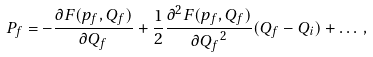<formula> <loc_0><loc_0><loc_500><loc_500>P _ { f } = - \frac { \partial F ( p _ { f } , Q _ { f } ) } { \partial Q _ { f } } + \frac { 1 } { 2 } \frac { \partial ^ { 2 } F ( p _ { f } , Q _ { f } ) } { \partial { Q _ { f } } ^ { 2 } } ( Q _ { f } - Q _ { i } ) + \dots \, ,</formula> 